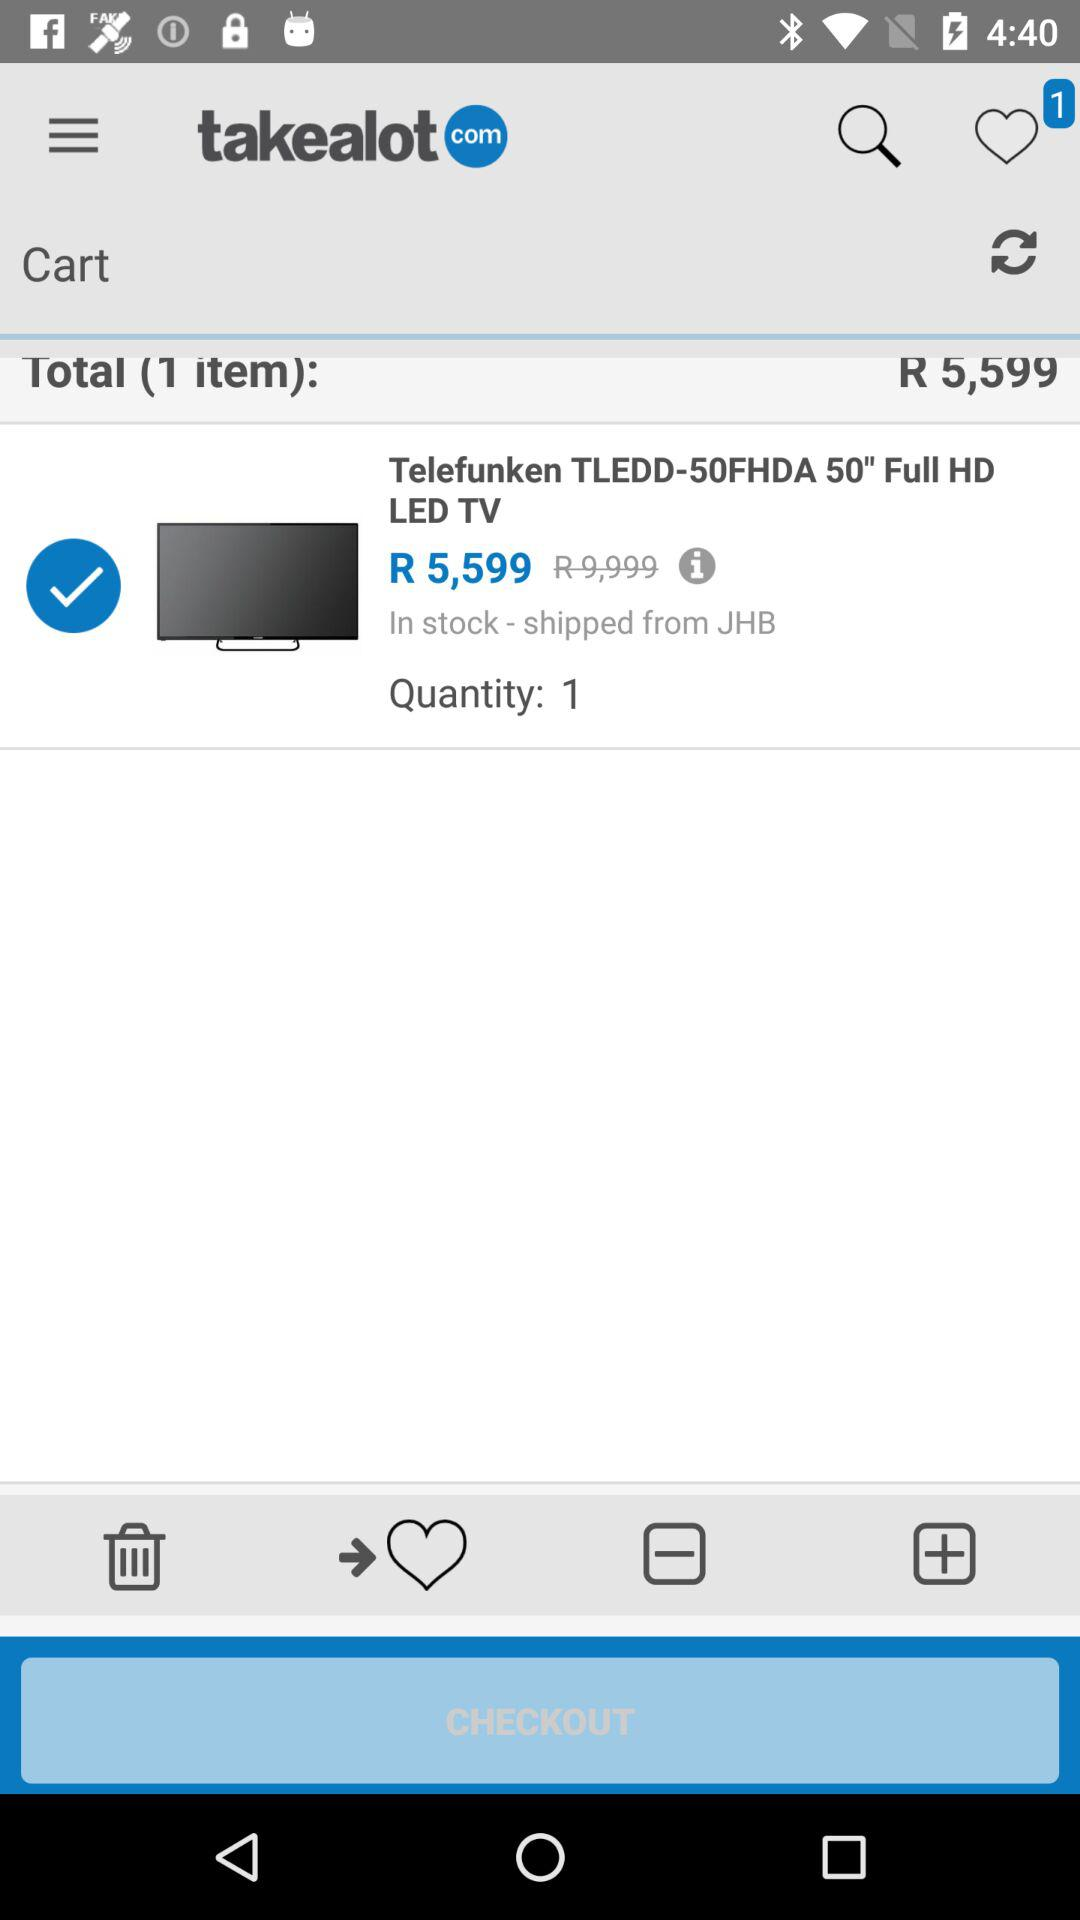What is the price of TLEDD-50FHDA 50"? The price is R5,599. 